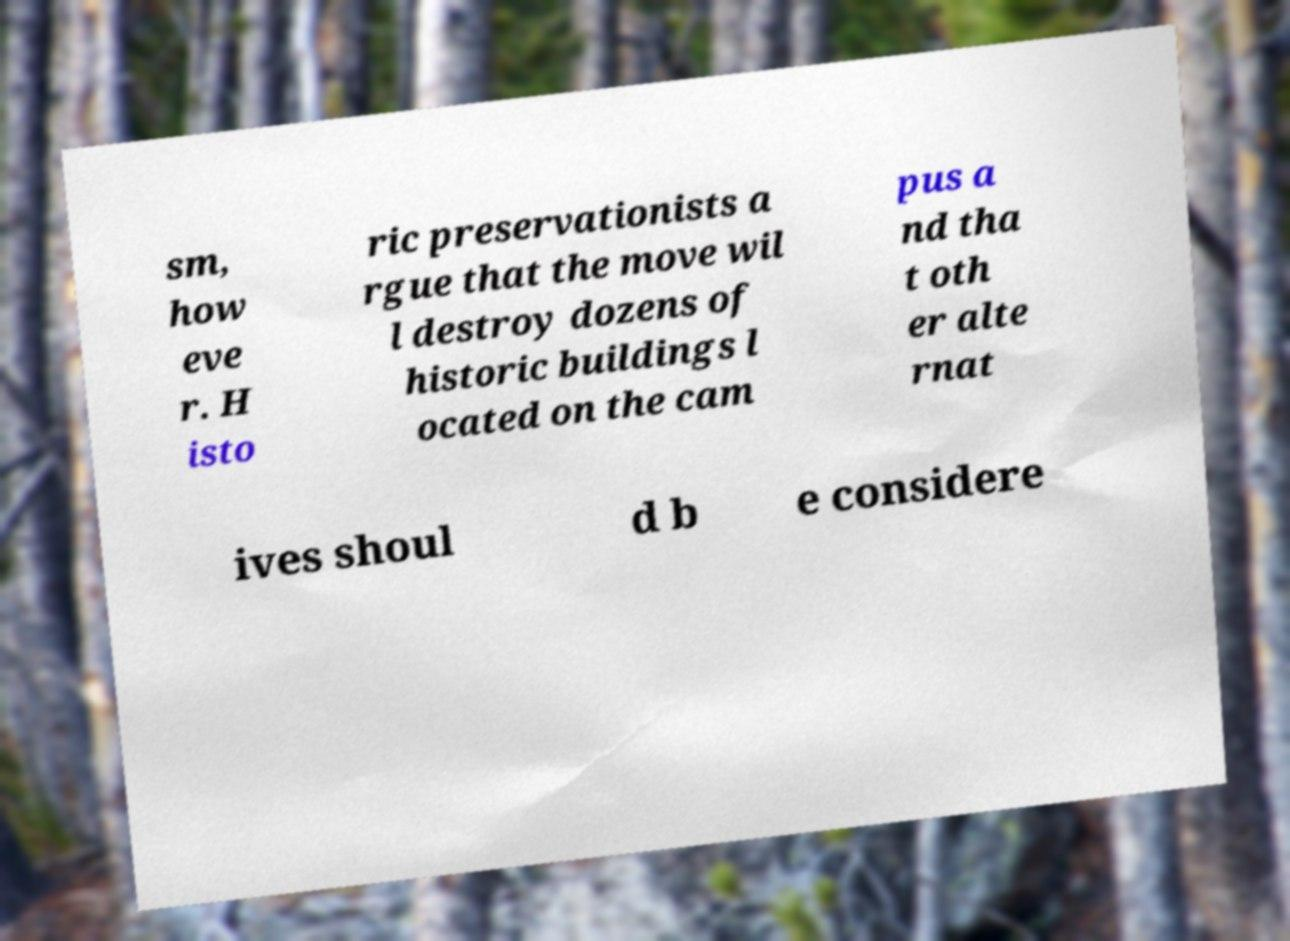Could you extract and type out the text from this image? sm, how eve r. H isto ric preservationists a rgue that the move wil l destroy dozens of historic buildings l ocated on the cam pus a nd tha t oth er alte rnat ives shoul d b e considere 